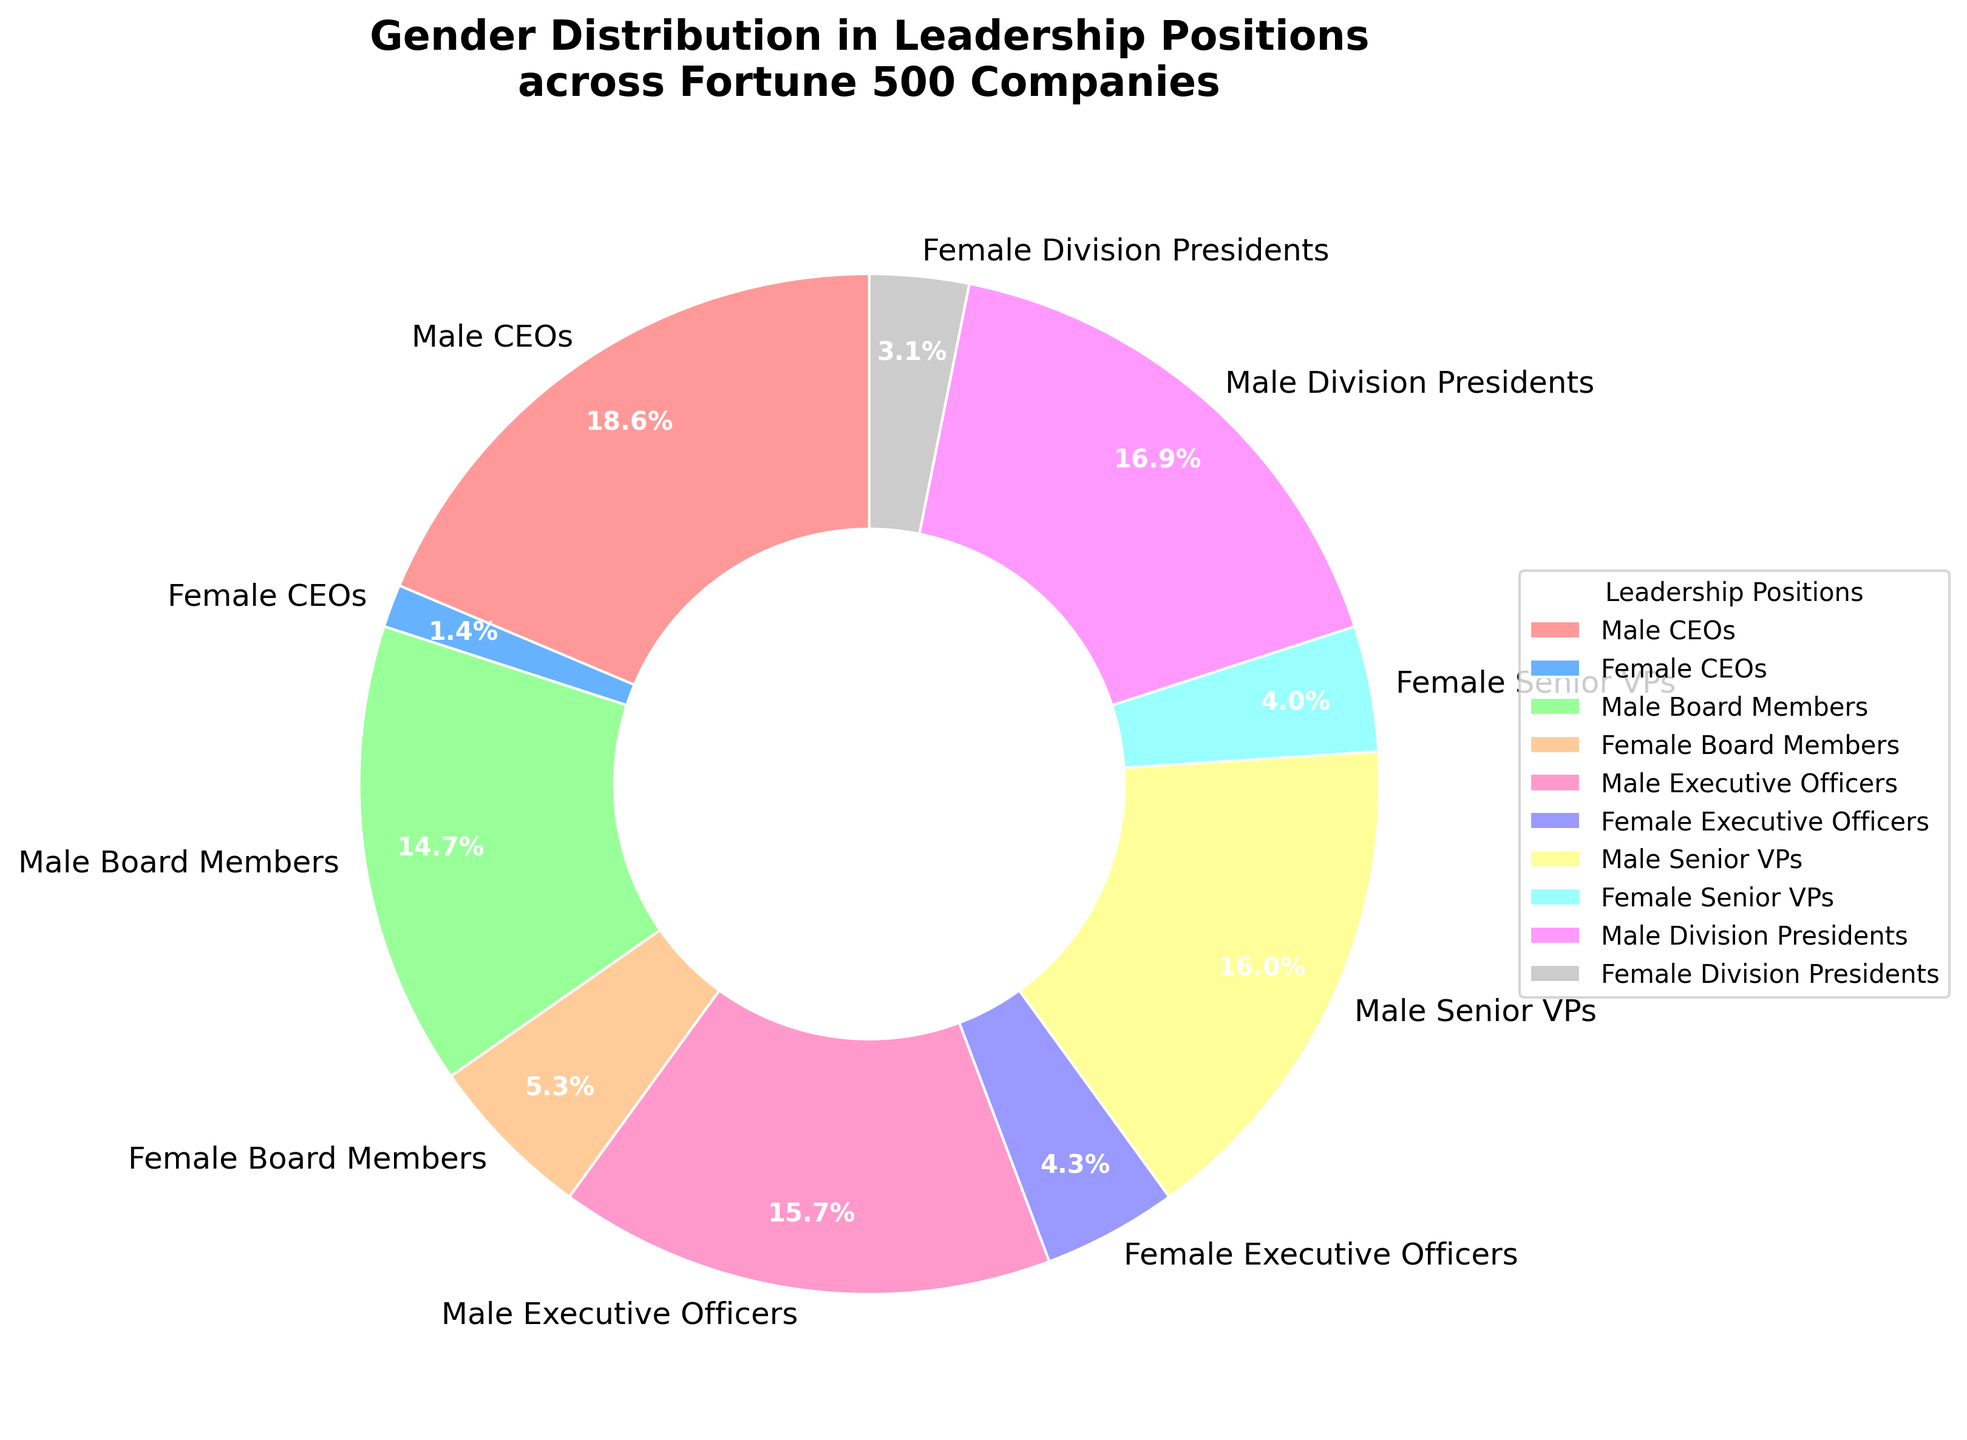What is the percentage of Female CEOs in Fortune 500 companies? To find the percentage of Female CEOs, look at the corresponding wedge in the pie chart labeled "Female CEOs". It is labeled 6.8%.
Answer: 6.8% Compare the percentage of Male CEOs to Male Board Members. Which one has a higher percentage? To determine which group has a higher percentage, look at the wedges labeled "Male CEOs" and "Male Board Members". Male CEOs have 93.2% and Male Board Members have 73.5%, so Male CEOs have a higher percentage.
Answer: Male CEOs What is the combined percentage of Female Executive Officers and Female Senior VPs? Add the percentages of "Female Executive Officers" (21.3%) and "Female Senior VPs" (19.9%) to get the combined percentage. 21.3% + 19.9% = 41.2%.
Answer: 41.2% Which leadership position has the lowest percentage of females and what is the percentage? Look for the smallest percentage among the female categories. The "Female CEOs" wedge is the smallest at 6.8%.
Answer: Female CEOs, 6.8% What is the difference in percentage between Male Division Presidents and Female Division Presidents? Subtract the percentage of "Female Division Presidents" (15.7%) from "Male Division Presidents" (84.3%) to find the difference. 84.3% - 15.7% = 68.6%.
Answer: 68.6% What is the total percentage of males in all leadership positions combined? Add the percentages of all male categories: Male CEOs (93.2%), Male Board Members (73.5%), Male Executive Officers (78.7%), Male Senior VPs (80.1%), and Male Division Presidents (84.3%). 93.2% + 73.5% + 78.7% + 80.1% + 84.3% = 409.8%.
Answer: 409.8% Compare the ratio of Male Executive Officers to Female Executive Officers. What is this ratio? To find the ratio, divide the percentage of Male Executive Officers (78.7%) by the percentage of Female Executive Officers (21.3%). 78.7 / 21.3 ≈ 3.7:1.
Answer: 3.7:1 Which category has a visual attribute indicating the largest gap between male and female percentages? By visually assessing the pie chart, the segment showing the largest gap between male and female categories is "CEOs," where the male segment (93.2%) substantially outweighs the female segment (6.8%).
Answer: CEOs 